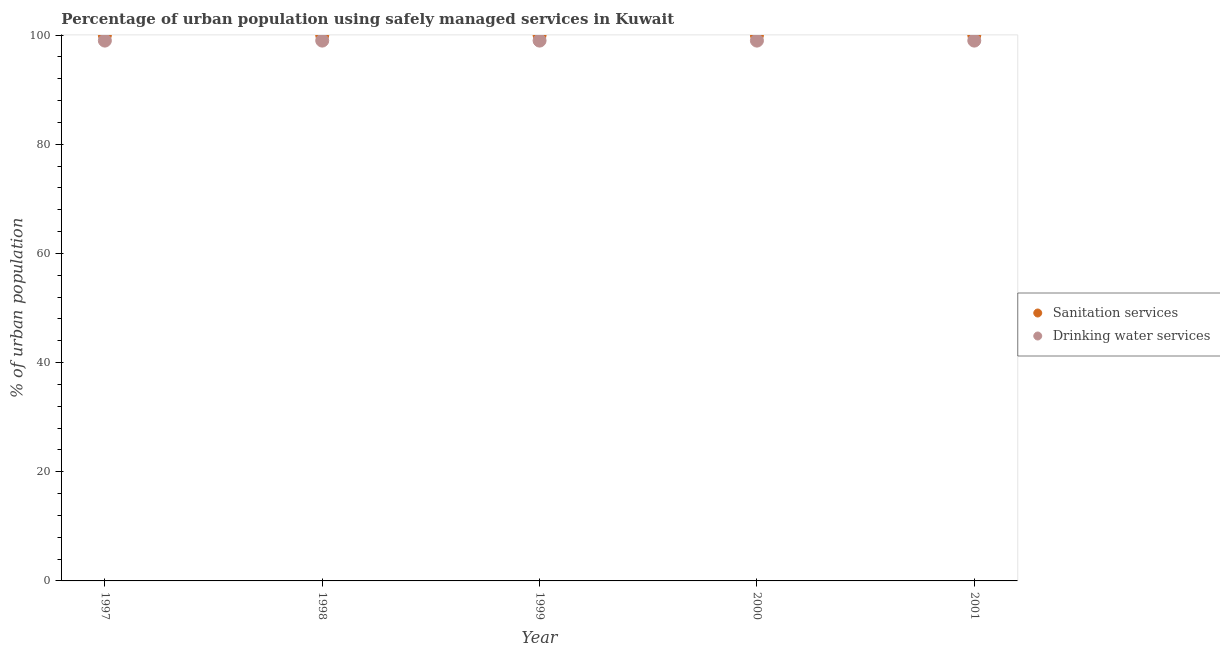What is the percentage of urban population who used drinking water services in 2000?
Give a very brief answer. 99. Across all years, what is the maximum percentage of urban population who used drinking water services?
Make the answer very short. 99. Across all years, what is the minimum percentage of urban population who used sanitation services?
Ensure brevity in your answer.  100. What is the total percentage of urban population who used sanitation services in the graph?
Provide a succinct answer. 500. What is the difference between the percentage of urban population who used drinking water services in 1997 and that in 2000?
Your answer should be compact. 0. What is the difference between the percentage of urban population who used drinking water services in 2001 and the percentage of urban population who used sanitation services in 2000?
Offer a very short reply. -1. What is the average percentage of urban population who used sanitation services per year?
Your response must be concise. 100. In the year 1997, what is the difference between the percentage of urban population who used drinking water services and percentage of urban population who used sanitation services?
Offer a terse response. -1. In how many years, is the percentage of urban population who used drinking water services greater than 92 %?
Provide a succinct answer. 5. What is the difference between the highest and the second highest percentage of urban population who used drinking water services?
Your response must be concise. 0. What is the difference between the highest and the lowest percentage of urban population who used sanitation services?
Ensure brevity in your answer.  0. In how many years, is the percentage of urban population who used sanitation services greater than the average percentage of urban population who used sanitation services taken over all years?
Offer a very short reply. 0. Is the sum of the percentage of urban population who used drinking water services in 1997 and 2001 greater than the maximum percentage of urban population who used sanitation services across all years?
Ensure brevity in your answer.  Yes. Does the percentage of urban population who used sanitation services monotonically increase over the years?
Provide a short and direct response. No. How many years are there in the graph?
Your answer should be compact. 5. Does the graph contain any zero values?
Your answer should be compact. No. Where does the legend appear in the graph?
Your answer should be compact. Center right. What is the title of the graph?
Make the answer very short. Percentage of urban population using safely managed services in Kuwait. What is the label or title of the X-axis?
Make the answer very short. Year. What is the label or title of the Y-axis?
Provide a succinct answer. % of urban population. What is the % of urban population of Sanitation services in 1997?
Offer a terse response. 100. What is the % of urban population in Drinking water services in 1997?
Offer a terse response. 99. What is the % of urban population of Sanitation services in 1998?
Provide a short and direct response. 100. What is the % of urban population in Drinking water services in 1999?
Make the answer very short. 99. Across all years, what is the maximum % of urban population of Drinking water services?
Provide a succinct answer. 99. Across all years, what is the minimum % of urban population in Sanitation services?
Ensure brevity in your answer.  100. Across all years, what is the minimum % of urban population of Drinking water services?
Give a very brief answer. 99. What is the total % of urban population of Drinking water services in the graph?
Give a very brief answer. 495. What is the difference between the % of urban population in Sanitation services in 1997 and that in 1998?
Provide a succinct answer. 0. What is the difference between the % of urban population in Drinking water services in 1997 and that in 1998?
Provide a succinct answer. 0. What is the difference between the % of urban population in Sanitation services in 1997 and that in 1999?
Provide a succinct answer. 0. What is the difference between the % of urban population in Drinking water services in 1997 and that in 2001?
Give a very brief answer. 0. What is the difference between the % of urban population in Drinking water services in 1998 and that in 2000?
Offer a very short reply. 0. What is the difference between the % of urban population in Drinking water services in 1999 and that in 2000?
Make the answer very short. 0. What is the difference between the % of urban population of Sanitation services in 1999 and that in 2001?
Your answer should be very brief. 0. What is the difference between the % of urban population in Sanitation services in 2000 and that in 2001?
Your response must be concise. 0. What is the difference between the % of urban population in Sanitation services in 1997 and the % of urban population in Drinking water services in 1999?
Your response must be concise. 1. What is the difference between the % of urban population in Sanitation services in 1998 and the % of urban population in Drinking water services in 2000?
Provide a short and direct response. 1. What is the difference between the % of urban population in Sanitation services in 1998 and the % of urban population in Drinking water services in 2001?
Your response must be concise. 1. What is the difference between the % of urban population in Sanitation services in 2000 and the % of urban population in Drinking water services in 2001?
Your answer should be very brief. 1. What is the average % of urban population of Drinking water services per year?
Offer a very short reply. 99. In the year 2001, what is the difference between the % of urban population in Sanitation services and % of urban population in Drinking water services?
Your answer should be very brief. 1. What is the ratio of the % of urban population of Drinking water services in 1997 to that in 1998?
Ensure brevity in your answer.  1. What is the ratio of the % of urban population in Drinking water services in 1997 to that in 1999?
Your response must be concise. 1. What is the ratio of the % of urban population of Sanitation services in 1997 to that in 2001?
Your answer should be very brief. 1. What is the ratio of the % of urban population in Drinking water services in 1997 to that in 2001?
Make the answer very short. 1. What is the ratio of the % of urban population of Sanitation services in 1998 to that in 2000?
Your answer should be compact. 1. What is the ratio of the % of urban population in Drinking water services in 1998 to that in 2001?
Your response must be concise. 1. What is the difference between the highest and the second highest % of urban population of Sanitation services?
Ensure brevity in your answer.  0. 